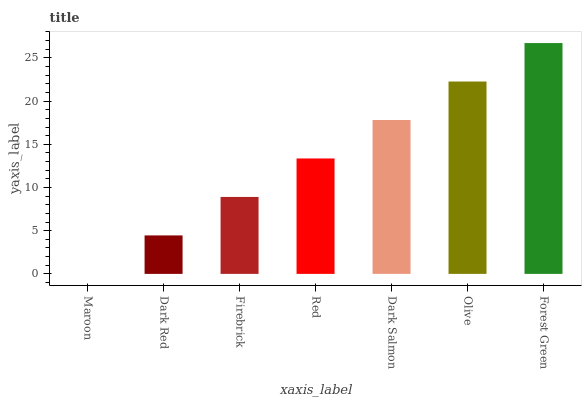Is Maroon the minimum?
Answer yes or no. Yes. Is Forest Green the maximum?
Answer yes or no. Yes. Is Dark Red the minimum?
Answer yes or no. No. Is Dark Red the maximum?
Answer yes or no. No. Is Dark Red greater than Maroon?
Answer yes or no. Yes. Is Maroon less than Dark Red?
Answer yes or no. Yes. Is Maroon greater than Dark Red?
Answer yes or no. No. Is Dark Red less than Maroon?
Answer yes or no. No. Is Red the high median?
Answer yes or no. Yes. Is Red the low median?
Answer yes or no. Yes. Is Forest Green the high median?
Answer yes or no. No. Is Dark Red the low median?
Answer yes or no. No. 